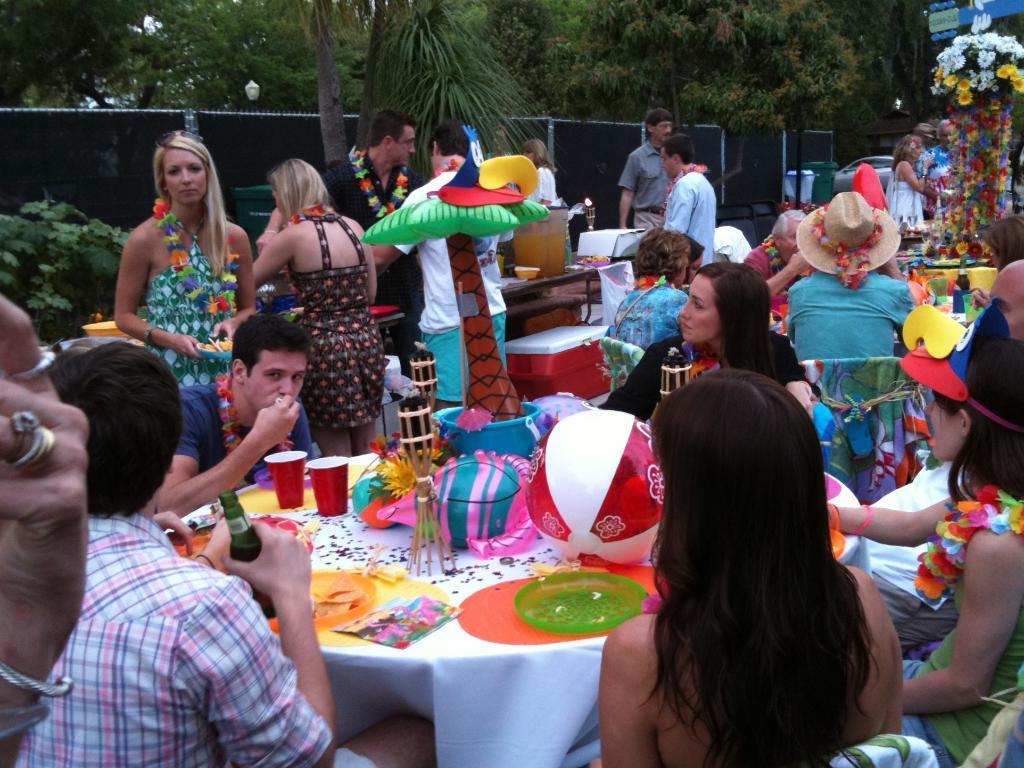Can you describe this image briefly? There are so many people in fence some are sitting drinking and eating and some are standing and there are some trees. 